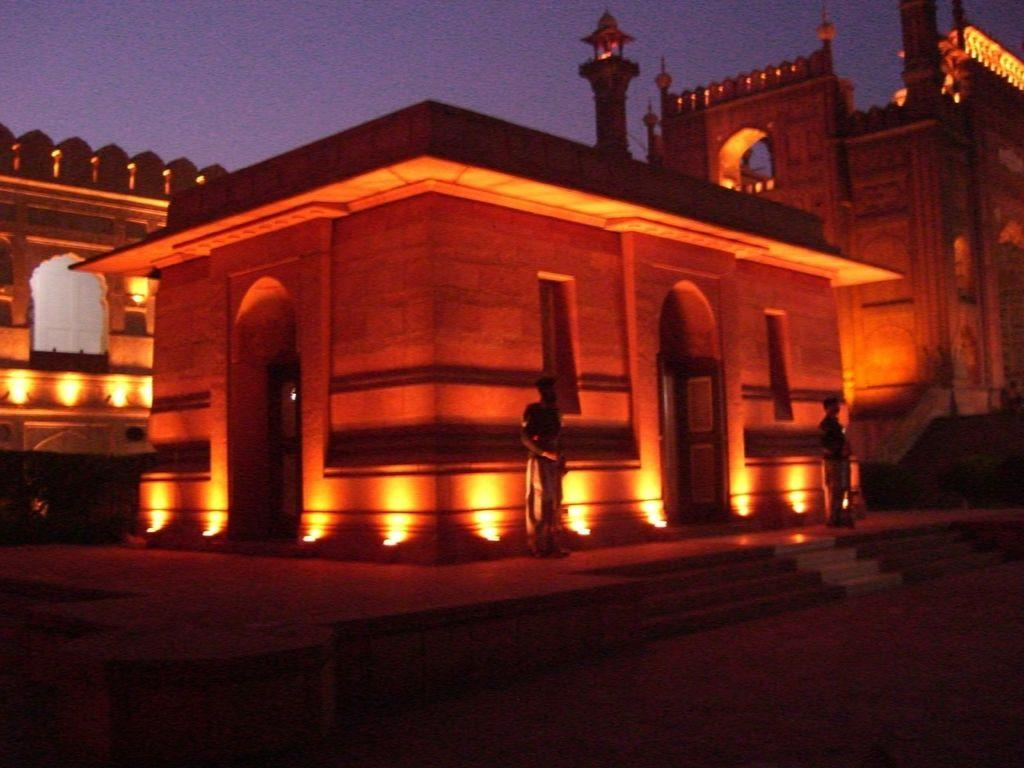What type of structure is the main subject in the image? There is a monumental building in the image. Where is the building located? The building is situated over a place. What can be seen in the image besides the building? There are lights present in the image. Are there any people visible in the image? Yes, two men are standing in the front of the image. What type of suit is the ant wearing on the page in the image? There is no ant or page present in the image, and therefore no suit can be observed. 